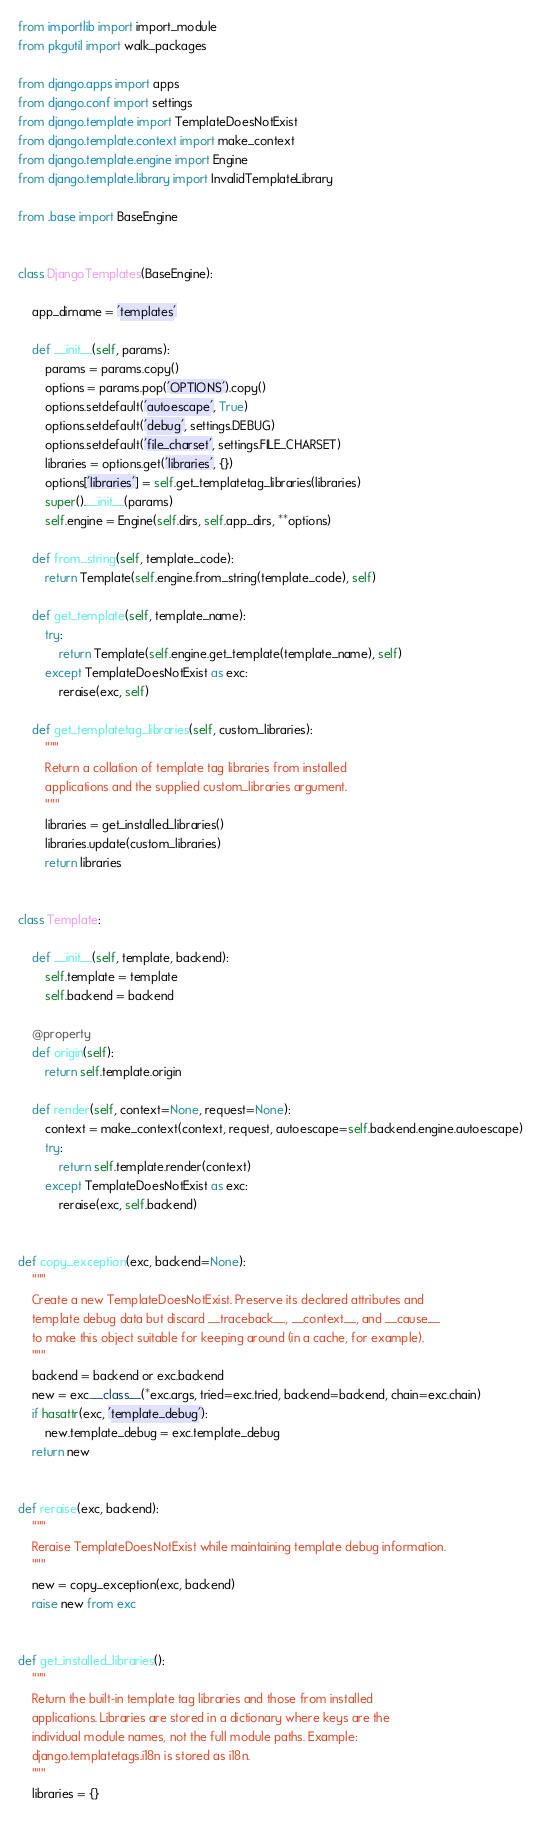<code> <loc_0><loc_0><loc_500><loc_500><_Python_>from importlib import import_module
from pkgutil import walk_packages

from django.apps import apps
from django.conf import settings
from django.template import TemplateDoesNotExist
from django.template.context import make_context
from django.template.engine import Engine
from django.template.library import InvalidTemplateLibrary

from .base import BaseEngine


class DjangoTemplates(BaseEngine):

    app_dirname = 'templates'

    def __init__(self, params):
        params = params.copy()
        options = params.pop('OPTIONS').copy()
        options.setdefault('autoescape', True)
        options.setdefault('debug', settings.DEBUG)
        options.setdefault('file_charset', settings.FILE_CHARSET)
        libraries = options.get('libraries', {})
        options['libraries'] = self.get_templatetag_libraries(libraries)
        super().__init__(params)
        self.engine = Engine(self.dirs, self.app_dirs, **options)

    def from_string(self, template_code):
        return Template(self.engine.from_string(template_code), self)

    def get_template(self, template_name):
        try:
            return Template(self.engine.get_template(template_name), self)
        except TemplateDoesNotExist as exc:
            reraise(exc, self)

    def get_templatetag_libraries(self, custom_libraries):
        """
        Return a collation of template tag libraries from installed
        applications and the supplied custom_libraries argument.
        """
        libraries = get_installed_libraries()
        libraries.update(custom_libraries)
        return libraries


class Template:

    def __init__(self, template, backend):
        self.template = template
        self.backend = backend

    @property
    def origin(self):
        return self.template.origin

    def render(self, context=None, request=None):
        context = make_context(context, request, autoescape=self.backend.engine.autoescape)
        try:
            return self.template.render(context)
        except TemplateDoesNotExist as exc:
            reraise(exc, self.backend)


def copy_exception(exc, backend=None):
    """
    Create a new TemplateDoesNotExist. Preserve its declared attributes and
    template debug data but discard __traceback__, __context__, and __cause__
    to make this object suitable for keeping around (in a cache, for example).
    """
    backend = backend or exc.backend
    new = exc.__class__(*exc.args, tried=exc.tried, backend=backend, chain=exc.chain)
    if hasattr(exc, 'template_debug'):
        new.template_debug = exc.template_debug
    return new


def reraise(exc, backend):
    """
    Reraise TemplateDoesNotExist while maintaining template debug information.
    """
    new = copy_exception(exc, backend)
    raise new from exc


def get_installed_libraries():
    """
    Return the built-in template tag libraries and those from installed
    applications. Libraries are stored in a dictionary where keys are the
    individual module names, not the full module paths. Example:
    django.templatetags.i18n is stored as i18n.
    """
    libraries = {}</code> 